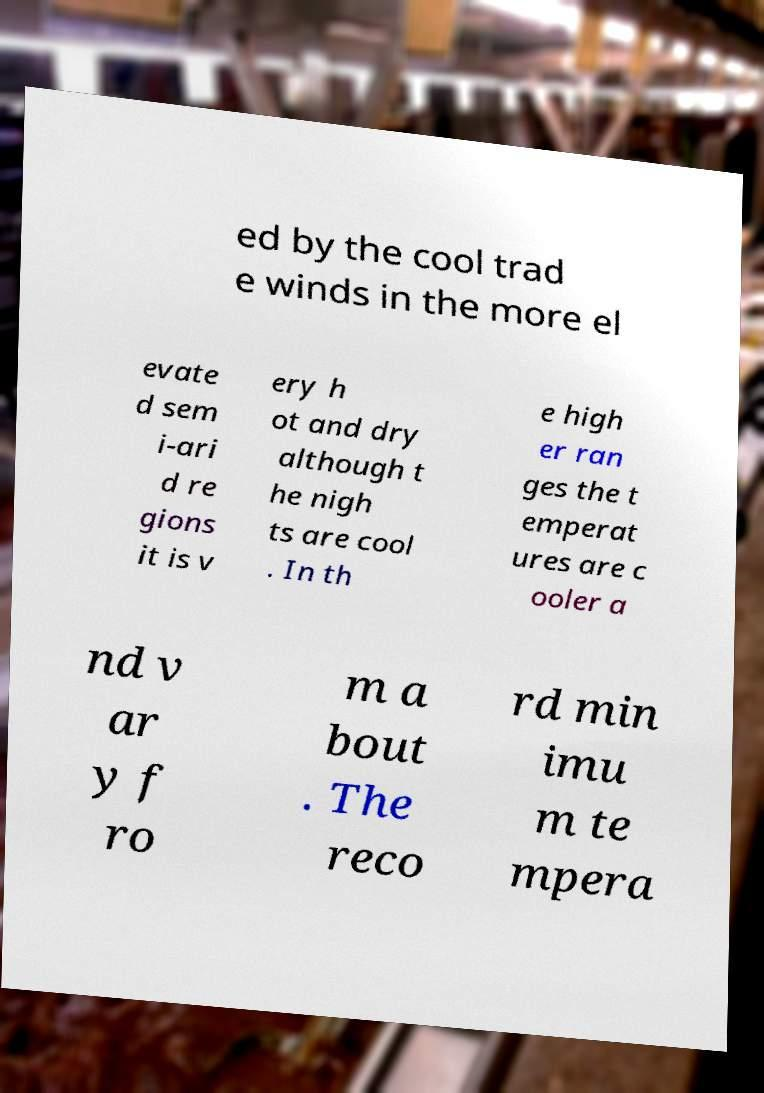Could you assist in decoding the text presented in this image and type it out clearly? ed by the cool trad e winds in the more el evate d sem i-ari d re gions it is v ery h ot and dry although t he nigh ts are cool . In th e high er ran ges the t emperat ures are c ooler a nd v ar y f ro m a bout . The reco rd min imu m te mpera 